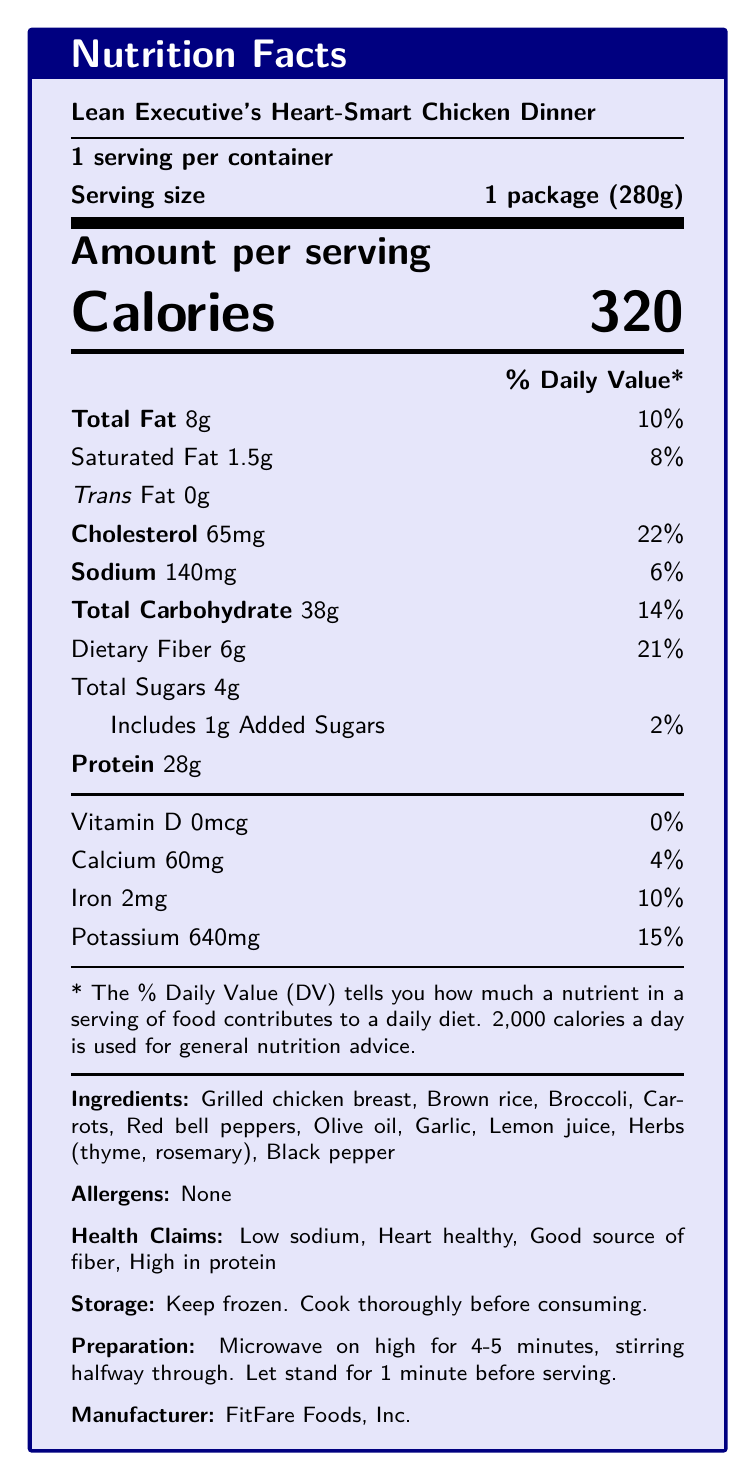who is the target audience for the Lean Executive's Heart-Smart Chicken Dinner? According to the document, the target audience is specified as "Health-conscious business professionals with limited time for meal preparation."
Answer: Health-conscious business professionals with limited time for meal preparation what is the serving size for the Lean Executive's Heart-Smart Chicken Dinner? The serving size is clearly mentioned in the document as "1 package (280g)."
Answer: 1 package (280g) how many calories are in one serving? The document states that there are 320 calories in one serving.
Answer: 320 what percentage of the daily value (%DV) of sodium does one serving contain? The document shows that one serving contains 140mg of sodium, which is 6% of the daily value.
Answer: 6% list three main ingredients of the Lean Executive's Heart-Smart Chicken Dinner. The document lists the ingredients, and three of the main ones are "Grilled chicken breast," "Brown rice," and "Broccoli."
Answer: Grilled chicken breast, Brown rice, Broccoli how much dietary fiber is in one serving? One serving contains 6g of dietary fiber as mentioned in the document.
Answer: 6g what is the amount of protein per serving? The amount of protein per serving is stated as 28g in the document.
Answer: 28g which of the following is not listed as an ingredient? A. Garlic B. Olive oil C. Wheat The listed ingredients are "Grilled chicken breast," "Brown rice," "Broccoli," "Carrots," "Red bell peppers," "Olive oil," "Garlic," "Lemon juice," "Herbs (thyme, rosemary)," and "Black pepper." Wheat is not mentioned.
Answer: C how should you prepare this frozen dinner? A. Bake it in the oven for 20 minutes B. Microwave on high for 4-5 minutes, stirring halfway through C. Boil it for 10 minutes The preparation instructions are to "Microwave on high for 4-5 minutes, stirring halfway through."
Answer: B is there any vitamin D in this meal? The document states that the vitamin D content is 0mcg, which is 0% of the daily value.
Answer: No summarize the main benefits of this product. According to the document, the product benefits are "Convenient for busy professionals," "Supports cardiovascular health," "Balanced macronutrients for sustained energy," and "No artificial preservatives or additives."
Answer: The Lean Executive's Heart-Smart Chicken Dinner is convenient for busy professionals, supports cardiovascular health, has balanced macronutrients for sustained energy, and contains no artificial preservatives or additives. what is the calcium percentage daily value (%DV) in this meal? The document states that the calcium content is 60mg, which is 4% of the daily value.
Answer: 4% what is the manufacturer's name? The document mentions that the manufacturer is "FitFare Foods, Inc."
Answer: FitFare Foods, Inc. can this meal help in managing weight for health-conscious professionals? The document does not provide specific information about weight management, only details on nutrients and some health benefits.
Answer: Cannot be determined is the product free from artificial preservatives or additives? According to the product benefits listed, it contains "No artificial preservatives or additives."
Answer: Yes what are the declared health claims for this meal? The document lists the health claims as "Low sodium," "Heart healthy," "Good source of fiber," and "High in protein."
Answer: Low sodium, Heart healthy, Good source of fiber, High in protein what are the storage instructions for this meal? The storage instructions in the document state "Keep frozen. Cook thoroughly before consuming."
Answer: Keep frozen. Cook thoroughly before consuming. what percentage of the daily value of potassium does one serving provide? The document mentions that the potassium content is 640mg, which is 15% of the daily value.
Answer: 15% 